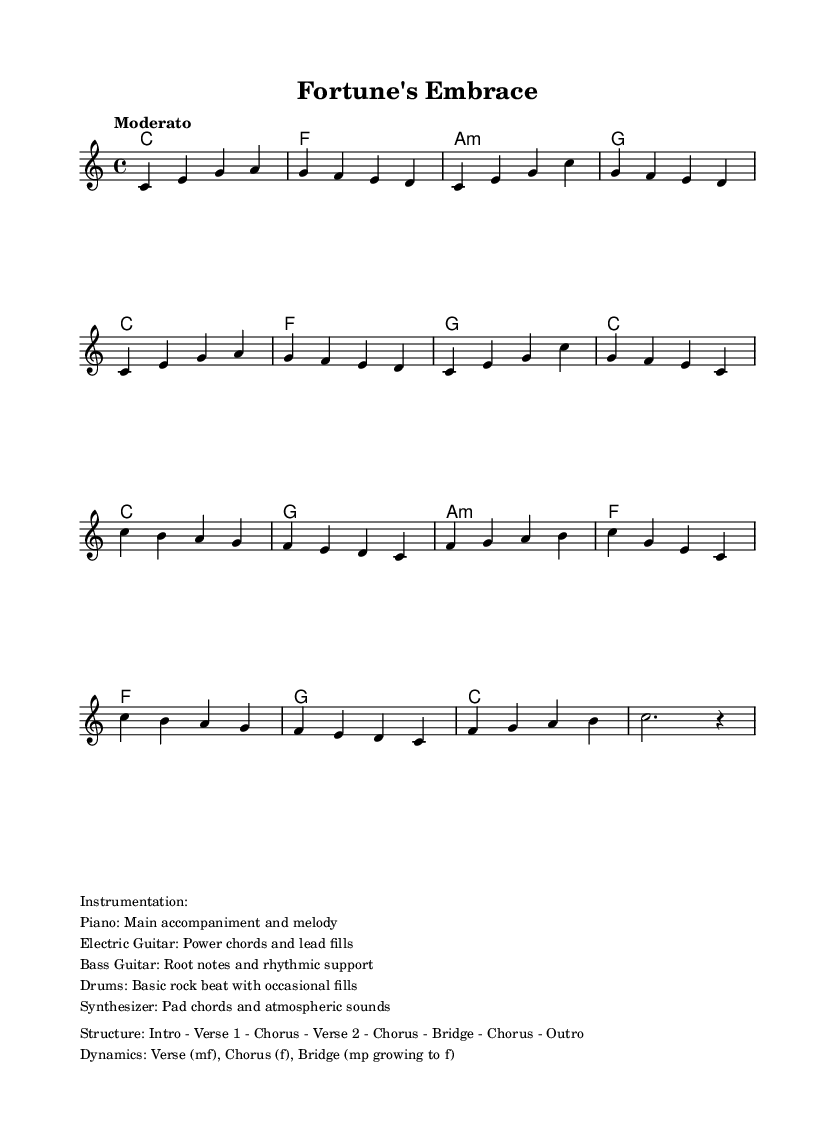What is the key signature of this music? The key signature is stated in the global block of the code, which indicates it is C major. This means there are no sharps or flats included in the key signature.
Answer: C major What is the time signature of the piece? The time signature is noted in the global block of the code as 4/4, which indicates that there are four beats per measure and the quarter note gets one beat.
Answer: 4/4 What is the tempo marking for this piece? The tempo marking is noted in the global block as "Moderato," which describes the speed of the music as moderate or at a medium pace.
Answer: Moderato How many verses are there in the structure? By analyzing the structure section in the markup, it indicates there are two verses: Verse 1 and Verse 2, mentioned distinctly.
Answer: 2 What instruments are used in this music? The instrumentation is described in the markup section, listing the Piano, Electric Guitar, Bass Guitar, Drums, and Synthesizer. This gives a clear indication of the instruments involved in the arrangement.
Answer: Piano, Electric Guitar, Bass Guitar, Drums, Synthesizer In what dynamic level does the chorus start? The dynamics section in the markup indicates that the chorus starts at a 'forte' dynamic level, which calls for a loud volume in the music as it contrasts with the 'mf' (mezzo-forte) in the verses.
Answer: f What chord follows the 'g' note in the chorus? By reviewing the harmonies presented in chord mode under the chorus section, the chord following the 'g' note in the chorus is an 'a minor'. This can be seen directly in the notation.
Answer: a:m 